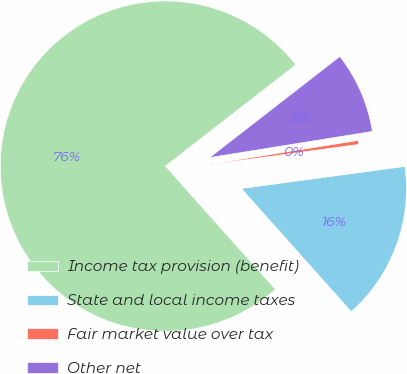<chart> <loc_0><loc_0><loc_500><loc_500><pie_chart><fcel>Income tax provision (benefit)<fcel>State and local income taxes<fcel>Fair market value over tax<fcel>Other net<nl><fcel>76.1%<fcel>15.54%<fcel>0.4%<fcel>7.97%<nl></chart> 